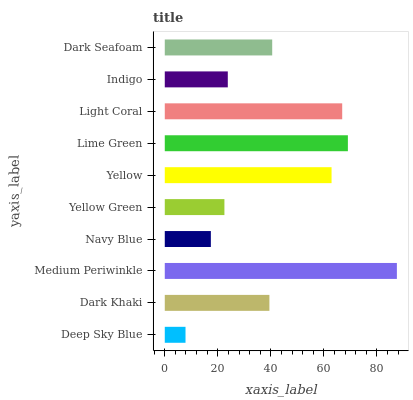Is Deep Sky Blue the minimum?
Answer yes or no. Yes. Is Medium Periwinkle the maximum?
Answer yes or no. Yes. Is Dark Khaki the minimum?
Answer yes or no. No. Is Dark Khaki the maximum?
Answer yes or no. No. Is Dark Khaki greater than Deep Sky Blue?
Answer yes or no. Yes. Is Deep Sky Blue less than Dark Khaki?
Answer yes or no. Yes. Is Deep Sky Blue greater than Dark Khaki?
Answer yes or no. No. Is Dark Khaki less than Deep Sky Blue?
Answer yes or no. No. Is Dark Seafoam the high median?
Answer yes or no. Yes. Is Dark Khaki the low median?
Answer yes or no. Yes. Is Medium Periwinkle the high median?
Answer yes or no. No. Is Navy Blue the low median?
Answer yes or no. No. 